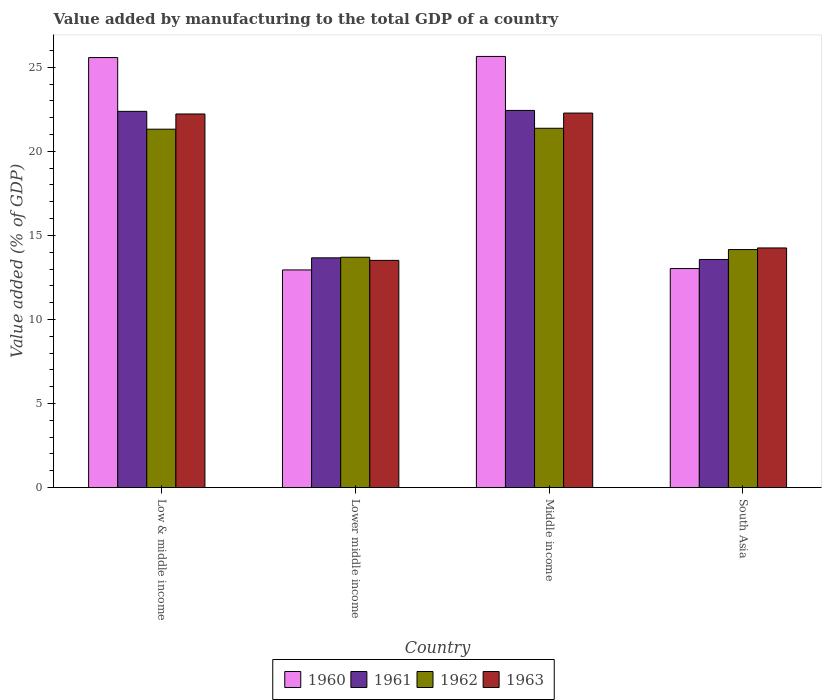How many different coloured bars are there?
Your answer should be compact. 4. How many groups of bars are there?
Make the answer very short. 4. Are the number of bars per tick equal to the number of legend labels?
Offer a terse response. Yes. Are the number of bars on each tick of the X-axis equal?
Make the answer very short. Yes. How many bars are there on the 4th tick from the left?
Ensure brevity in your answer.  4. How many bars are there on the 4th tick from the right?
Keep it short and to the point. 4. In how many cases, is the number of bars for a given country not equal to the number of legend labels?
Make the answer very short. 0. What is the value added by manufacturing to the total GDP in 1960 in Middle income?
Your answer should be compact. 25.65. Across all countries, what is the maximum value added by manufacturing to the total GDP in 1960?
Make the answer very short. 25.65. Across all countries, what is the minimum value added by manufacturing to the total GDP in 1960?
Your response must be concise. 12.95. In which country was the value added by manufacturing to the total GDP in 1960 maximum?
Offer a terse response. Middle income. In which country was the value added by manufacturing to the total GDP in 1962 minimum?
Offer a very short reply. Lower middle income. What is the total value added by manufacturing to the total GDP in 1961 in the graph?
Give a very brief answer. 72.05. What is the difference between the value added by manufacturing to the total GDP in 1960 in Low & middle income and that in Middle income?
Your answer should be compact. -0.07. What is the difference between the value added by manufacturing to the total GDP in 1962 in Lower middle income and the value added by manufacturing to the total GDP in 1963 in Middle income?
Your answer should be very brief. -8.57. What is the average value added by manufacturing to the total GDP in 1963 per country?
Provide a succinct answer. 18.07. What is the difference between the value added by manufacturing to the total GDP of/in 1960 and value added by manufacturing to the total GDP of/in 1962 in Middle income?
Your answer should be very brief. 4.27. What is the ratio of the value added by manufacturing to the total GDP in 1960 in Middle income to that in South Asia?
Provide a short and direct response. 1.97. Is the value added by manufacturing to the total GDP in 1960 in Low & middle income less than that in Lower middle income?
Provide a succinct answer. No. What is the difference between the highest and the second highest value added by manufacturing to the total GDP in 1960?
Ensure brevity in your answer.  12.62. What is the difference between the highest and the lowest value added by manufacturing to the total GDP in 1960?
Offer a terse response. 12.7. Is the sum of the value added by manufacturing to the total GDP in 1960 in Low & middle income and South Asia greater than the maximum value added by manufacturing to the total GDP in 1963 across all countries?
Your answer should be compact. Yes. What does the 1st bar from the left in Middle income represents?
Keep it short and to the point. 1960. What does the 1st bar from the right in Low & middle income represents?
Provide a short and direct response. 1963. Are all the bars in the graph horizontal?
Provide a short and direct response. No. How many countries are there in the graph?
Your response must be concise. 4. Does the graph contain grids?
Your answer should be very brief. No. How many legend labels are there?
Your answer should be very brief. 4. How are the legend labels stacked?
Offer a very short reply. Horizontal. What is the title of the graph?
Ensure brevity in your answer.  Value added by manufacturing to the total GDP of a country. Does "1979" appear as one of the legend labels in the graph?
Give a very brief answer. No. What is the label or title of the X-axis?
Provide a short and direct response. Country. What is the label or title of the Y-axis?
Give a very brief answer. Value added (% of GDP). What is the Value added (% of GDP) in 1960 in Low & middle income?
Your response must be concise. 25.58. What is the Value added (% of GDP) in 1961 in Low & middle income?
Provide a short and direct response. 22.38. What is the Value added (% of GDP) of 1962 in Low & middle income?
Offer a terse response. 21.32. What is the Value added (% of GDP) in 1963 in Low & middle income?
Your answer should be compact. 22.22. What is the Value added (% of GDP) in 1960 in Lower middle income?
Ensure brevity in your answer.  12.95. What is the Value added (% of GDP) of 1961 in Lower middle income?
Keep it short and to the point. 13.67. What is the Value added (% of GDP) in 1962 in Lower middle income?
Your answer should be very brief. 13.7. What is the Value added (% of GDP) of 1963 in Lower middle income?
Your answer should be very brief. 13.52. What is the Value added (% of GDP) of 1960 in Middle income?
Provide a short and direct response. 25.65. What is the Value added (% of GDP) of 1961 in Middle income?
Give a very brief answer. 22.44. What is the Value added (% of GDP) in 1962 in Middle income?
Your response must be concise. 21.37. What is the Value added (% of GDP) of 1963 in Middle income?
Make the answer very short. 22.28. What is the Value added (% of GDP) of 1960 in South Asia?
Provide a short and direct response. 13.03. What is the Value added (% of GDP) of 1961 in South Asia?
Give a very brief answer. 13.57. What is the Value added (% of GDP) of 1962 in South Asia?
Offer a terse response. 14.16. What is the Value added (% of GDP) of 1963 in South Asia?
Provide a succinct answer. 14.26. Across all countries, what is the maximum Value added (% of GDP) of 1960?
Your answer should be very brief. 25.65. Across all countries, what is the maximum Value added (% of GDP) in 1961?
Give a very brief answer. 22.44. Across all countries, what is the maximum Value added (% of GDP) in 1962?
Offer a terse response. 21.37. Across all countries, what is the maximum Value added (% of GDP) in 1963?
Offer a very short reply. 22.28. Across all countries, what is the minimum Value added (% of GDP) in 1960?
Your answer should be very brief. 12.95. Across all countries, what is the minimum Value added (% of GDP) of 1961?
Make the answer very short. 13.57. Across all countries, what is the minimum Value added (% of GDP) in 1962?
Your answer should be compact. 13.7. Across all countries, what is the minimum Value added (% of GDP) of 1963?
Your answer should be compact. 13.52. What is the total Value added (% of GDP) of 1960 in the graph?
Provide a short and direct response. 77.2. What is the total Value added (% of GDP) of 1961 in the graph?
Provide a succinct answer. 72.05. What is the total Value added (% of GDP) of 1962 in the graph?
Provide a succinct answer. 70.56. What is the total Value added (% of GDP) in 1963 in the graph?
Your answer should be very brief. 72.27. What is the difference between the Value added (% of GDP) in 1960 in Low & middle income and that in Lower middle income?
Your answer should be very brief. 12.63. What is the difference between the Value added (% of GDP) in 1961 in Low & middle income and that in Lower middle income?
Provide a succinct answer. 8.71. What is the difference between the Value added (% of GDP) of 1962 in Low & middle income and that in Lower middle income?
Provide a short and direct response. 7.62. What is the difference between the Value added (% of GDP) in 1963 in Low & middle income and that in Lower middle income?
Provide a short and direct response. 8.71. What is the difference between the Value added (% of GDP) in 1960 in Low & middle income and that in Middle income?
Make the answer very short. -0.07. What is the difference between the Value added (% of GDP) of 1961 in Low & middle income and that in Middle income?
Your answer should be very brief. -0.06. What is the difference between the Value added (% of GDP) in 1962 in Low & middle income and that in Middle income?
Offer a terse response. -0.05. What is the difference between the Value added (% of GDP) of 1963 in Low & middle income and that in Middle income?
Make the answer very short. -0.05. What is the difference between the Value added (% of GDP) in 1960 in Low & middle income and that in South Asia?
Provide a succinct answer. 12.55. What is the difference between the Value added (% of GDP) in 1961 in Low & middle income and that in South Asia?
Ensure brevity in your answer.  8.81. What is the difference between the Value added (% of GDP) of 1962 in Low & middle income and that in South Asia?
Keep it short and to the point. 7.16. What is the difference between the Value added (% of GDP) in 1963 in Low & middle income and that in South Asia?
Offer a very short reply. 7.97. What is the difference between the Value added (% of GDP) in 1960 in Lower middle income and that in Middle income?
Provide a short and direct response. -12.7. What is the difference between the Value added (% of GDP) of 1961 in Lower middle income and that in Middle income?
Offer a very short reply. -8.77. What is the difference between the Value added (% of GDP) in 1962 in Lower middle income and that in Middle income?
Ensure brevity in your answer.  -7.67. What is the difference between the Value added (% of GDP) in 1963 in Lower middle income and that in Middle income?
Offer a terse response. -8.76. What is the difference between the Value added (% of GDP) in 1960 in Lower middle income and that in South Asia?
Your answer should be compact. -0.08. What is the difference between the Value added (% of GDP) of 1961 in Lower middle income and that in South Asia?
Ensure brevity in your answer.  0.1. What is the difference between the Value added (% of GDP) of 1962 in Lower middle income and that in South Asia?
Provide a succinct answer. -0.46. What is the difference between the Value added (% of GDP) in 1963 in Lower middle income and that in South Asia?
Give a very brief answer. -0.74. What is the difference between the Value added (% of GDP) in 1960 in Middle income and that in South Asia?
Your answer should be compact. 12.62. What is the difference between the Value added (% of GDP) of 1961 in Middle income and that in South Asia?
Keep it short and to the point. 8.87. What is the difference between the Value added (% of GDP) in 1962 in Middle income and that in South Asia?
Your response must be concise. 7.21. What is the difference between the Value added (% of GDP) of 1963 in Middle income and that in South Asia?
Your answer should be very brief. 8.02. What is the difference between the Value added (% of GDP) in 1960 in Low & middle income and the Value added (% of GDP) in 1961 in Lower middle income?
Your response must be concise. 11.91. What is the difference between the Value added (% of GDP) in 1960 in Low & middle income and the Value added (% of GDP) in 1962 in Lower middle income?
Offer a terse response. 11.88. What is the difference between the Value added (% of GDP) in 1960 in Low & middle income and the Value added (% of GDP) in 1963 in Lower middle income?
Provide a short and direct response. 12.06. What is the difference between the Value added (% of GDP) of 1961 in Low & middle income and the Value added (% of GDP) of 1962 in Lower middle income?
Your answer should be compact. 8.68. What is the difference between the Value added (% of GDP) of 1961 in Low & middle income and the Value added (% of GDP) of 1963 in Lower middle income?
Offer a terse response. 8.86. What is the difference between the Value added (% of GDP) in 1962 in Low & middle income and the Value added (% of GDP) in 1963 in Lower middle income?
Provide a short and direct response. 7.8. What is the difference between the Value added (% of GDP) in 1960 in Low & middle income and the Value added (% of GDP) in 1961 in Middle income?
Offer a terse response. 3.14. What is the difference between the Value added (% of GDP) in 1960 in Low & middle income and the Value added (% of GDP) in 1962 in Middle income?
Keep it short and to the point. 4.21. What is the difference between the Value added (% of GDP) of 1960 in Low & middle income and the Value added (% of GDP) of 1963 in Middle income?
Your response must be concise. 3.3. What is the difference between the Value added (% of GDP) in 1961 in Low & middle income and the Value added (% of GDP) in 1962 in Middle income?
Keep it short and to the point. 1.01. What is the difference between the Value added (% of GDP) in 1961 in Low & middle income and the Value added (% of GDP) in 1963 in Middle income?
Your answer should be compact. 0.1. What is the difference between the Value added (% of GDP) of 1962 in Low & middle income and the Value added (% of GDP) of 1963 in Middle income?
Make the answer very short. -0.96. What is the difference between the Value added (% of GDP) in 1960 in Low & middle income and the Value added (% of GDP) in 1961 in South Asia?
Your answer should be very brief. 12.01. What is the difference between the Value added (% of GDP) of 1960 in Low & middle income and the Value added (% of GDP) of 1962 in South Asia?
Your answer should be very brief. 11.42. What is the difference between the Value added (% of GDP) in 1960 in Low & middle income and the Value added (% of GDP) in 1963 in South Asia?
Offer a terse response. 11.32. What is the difference between the Value added (% of GDP) of 1961 in Low & middle income and the Value added (% of GDP) of 1962 in South Asia?
Provide a short and direct response. 8.22. What is the difference between the Value added (% of GDP) of 1961 in Low & middle income and the Value added (% of GDP) of 1963 in South Asia?
Make the answer very short. 8.12. What is the difference between the Value added (% of GDP) of 1962 in Low & middle income and the Value added (% of GDP) of 1963 in South Asia?
Your answer should be compact. 7.06. What is the difference between the Value added (% of GDP) of 1960 in Lower middle income and the Value added (% of GDP) of 1961 in Middle income?
Provide a short and direct response. -9.49. What is the difference between the Value added (% of GDP) of 1960 in Lower middle income and the Value added (% of GDP) of 1962 in Middle income?
Offer a very short reply. -8.43. What is the difference between the Value added (% of GDP) of 1960 in Lower middle income and the Value added (% of GDP) of 1963 in Middle income?
Your answer should be very brief. -9.33. What is the difference between the Value added (% of GDP) in 1961 in Lower middle income and the Value added (% of GDP) in 1962 in Middle income?
Your answer should be compact. -7.71. What is the difference between the Value added (% of GDP) of 1961 in Lower middle income and the Value added (% of GDP) of 1963 in Middle income?
Offer a terse response. -8.61. What is the difference between the Value added (% of GDP) of 1962 in Lower middle income and the Value added (% of GDP) of 1963 in Middle income?
Provide a succinct answer. -8.57. What is the difference between the Value added (% of GDP) in 1960 in Lower middle income and the Value added (% of GDP) in 1961 in South Asia?
Offer a terse response. -0.62. What is the difference between the Value added (% of GDP) of 1960 in Lower middle income and the Value added (% of GDP) of 1962 in South Asia?
Give a very brief answer. -1.21. What is the difference between the Value added (% of GDP) of 1960 in Lower middle income and the Value added (% of GDP) of 1963 in South Asia?
Give a very brief answer. -1.31. What is the difference between the Value added (% of GDP) in 1961 in Lower middle income and the Value added (% of GDP) in 1962 in South Asia?
Offer a very short reply. -0.49. What is the difference between the Value added (% of GDP) of 1961 in Lower middle income and the Value added (% of GDP) of 1963 in South Asia?
Provide a short and direct response. -0.59. What is the difference between the Value added (% of GDP) in 1962 in Lower middle income and the Value added (% of GDP) in 1963 in South Asia?
Provide a short and direct response. -0.55. What is the difference between the Value added (% of GDP) in 1960 in Middle income and the Value added (% of GDP) in 1961 in South Asia?
Provide a short and direct response. 12.08. What is the difference between the Value added (% of GDP) in 1960 in Middle income and the Value added (% of GDP) in 1962 in South Asia?
Offer a very short reply. 11.49. What is the difference between the Value added (% of GDP) in 1960 in Middle income and the Value added (% of GDP) in 1963 in South Asia?
Give a very brief answer. 11.39. What is the difference between the Value added (% of GDP) in 1961 in Middle income and the Value added (% of GDP) in 1962 in South Asia?
Provide a short and direct response. 8.28. What is the difference between the Value added (% of GDP) of 1961 in Middle income and the Value added (% of GDP) of 1963 in South Asia?
Ensure brevity in your answer.  8.18. What is the difference between the Value added (% of GDP) of 1962 in Middle income and the Value added (% of GDP) of 1963 in South Asia?
Your answer should be very brief. 7.12. What is the average Value added (% of GDP) in 1960 per country?
Offer a terse response. 19.3. What is the average Value added (% of GDP) in 1961 per country?
Offer a very short reply. 18.01. What is the average Value added (% of GDP) in 1962 per country?
Offer a terse response. 17.64. What is the average Value added (% of GDP) of 1963 per country?
Offer a very short reply. 18.07. What is the difference between the Value added (% of GDP) in 1960 and Value added (% of GDP) in 1961 in Low & middle income?
Provide a short and direct response. 3.2. What is the difference between the Value added (% of GDP) of 1960 and Value added (% of GDP) of 1962 in Low & middle income?
Offer a terse response. 4.26. What is the difference between the Value added (% of GDP) of 1960 and Value added (% of GDP) of 1963 in Low & middle income?
Give a very brief answer. 3.35. What is the difference between the Value added (% of GDP) in 1961 and Value added (% of GDP) in 1962 in Low & middle income?
Keep it short and to the point. 1.06. What is the difference between the Value added (% of GDP) of 1961 and Value added (% of GDP) of 1963 in Low & middle income?
Give a very brief answer. 0.16. What is the difference between the Value added (% of GDP) of 1962 and Value added (% of GDP) of 1963 in Low & middle income?
Provide a short and direct response. -0.9. What is the difference between the Value added (% of GDP) in 1960 and Value added (% of GDP) in 1961 in Lower middle income?
Your response must be concise. -0.72. What is the difference between the Value added (% of GDP) in 1960 and Value added (% of GDP) in 1962 in Lower middle income?
Offer a terse response. -0.75. What is the difference between the Value added (% of GDP) in 1960 and Value added (% of GDP) in 1963 in Lower middle income?
Your answer should be compact. -0.57. What is the difference between the Value added (% of GDP) of 1961 and Value added (% of GDP) of 1962 in Lower middle income?
Offer a terse response. -0.04. What is the difference between the Value added (% of GDP) of 1961 and Value added (% of GDP) of 1963 in Lower middle income?
Provide a short and direct response. 0.15. What is the difference between the Value added (% of GDP) in 1962 and Value added (% of GDP) in 1963 in Lower middle income?
Your response must be concise. 0.19. What is the difference between the Value added (% of GDP) of 1960 and Value added (% of GDP) of 1961 in Middle income?
Offer a terse response. 3.21. What is the difference between the Value added (% of GDP) in 1960 and Value added (% of GDP) in 1962 in Middle income?
Your response must be concise. 4.27. What is the difference between the Value added (% of GDP) of 1960 and Value added (% of GDP) of 1963 in Middle income?
Provide a succinct answer. 3.37. What is the difference between the Value added (% of GDP) of 1961 and Value added (% of GDP) of 1962 in Middle income?
Your response must be concise. 1.06. What is the difference between the Value added (% of GDP) of 1961 and Value added (% of GDP) of 1963 in Middle income?
Provide a short and direct response. 0.16. What is the difference between the Value added (% of GDP) in 1962 and Value added (% of GDP) in 1963 in Middle income?
Offer a very short reply. -0.9. What is the difference between the Value added (% of GDP) in 1960 and Value added (% of GDP) in 1961 in South Asia?
Your answer should be very brief. -0.54. What is the difference between the Value added (% of GDP) in 1960 and Value added (% of GDP) in 1962 in South Asia?
Your answer should be very brief. -1.13. What is the difference between the Value added (% of GDP) of 1960 and Value added (% of GDP) of 1963 in South Asia?
Give a very brief answer. -1.23. What is the difference between the Value added (% of GDP) in 1961 and Value added (% of GDP) in 1962 in South Asia?
Ensure brevity in your answer.  -0.59. What is the difference between the Value added (% of GDP) in 1961 and Value added (% of GDP) in 1963 in South Asia?
Your response must be concise. -0.69. What is the difference between the Value added (% of GDP) of 1962 and Value added (% of GDP) of 1963 in South Asia?
Ensure brevity in your answer.  -0.1. What is the ratio of the Value added (% of GDP) in 1960 in Low & middle income to that in Lower middle income?
Your answer should be compact. 1.98. What is the ratio of the Value added (% of GDP) in 1961 in Low & middle income to that in Lower middle income?
Provide a succinct answer. 1.64. What is the ratio of the Value added (% of GDP) in 1962 in Low & middle income to that in Lower middle income?
Make the answer very short. 1.56. What is the ratio of the Value added (% of GDP) of 1963 in Low & middle income to that in Lower middle income?
Your answer should be very brief. 1.64. What is the ratio of the Value added (% of GDP) of 1960 in Low & middle income to that in Middle income?
Your response must be concise. 1. What is the ratio of the Value added (% of GDP) of 1961 in Low & middle income to that in Middle income?
Your answer should be very brief. 1. What is the ratio of the Value added (% of GDP) in 1962 in Low & middle income to that in Middle income?
Your answer should be compact. 1. What is the ratio of the Value added (% of GDP) in 1960 in Low & middle income to that in South Asia?
Provide a succinct answer. 1.96. What is the ratio of the Value added (% of GDP) of 1961 in Low & middle income to that in South Asia?
Your answer should be compact. 1.65. What is the ratio of the Value added (% of GDP) in 1962 in Low & middle income to that in South Asia?
Your answer should be very brief. 1.51. What is the ratio of the Value added (% of GDP) in 1963 in Low & middle income to that in South Asia?
Offer a very short reply. 1.56. What is the ratio of the Value added (% of GDP) of 1960 in Lower middle income to that in Middle income?
Provide a succinct answer. 0.5. What is the ratio of the Value added (% of GDP) of 1961 in Lower middle income to that in Middle income?
Provide a short and direct response. 0.61. What is the ratio of the Value added (% of GDP) of 1962 in Lower middle income to that in Middle income?
Your answer should be very brief. 0.64. What is the ratio of the Value added (% of GDP) of 1963 in Lower middle income to that in Middle income?
Offer a very short reply. 0.61. What is the ratio of the Value added (% of GDP) of 1960 in Lower middle income to that in South Asia?
Your response must be concise. 0.99. What is the ratio of the Value added (% of GDP) in 1963 in Lower middle income to that in South Asia?
Keep it short and to the point. 0.95. What is the ratio of the Value added (% of GDP) in 1960 in Middle income to that in South Asia?
Your answer should be very brief. 1.97. What is the ratio of the Value added (% of GDP) in 1961 in Middle income to that in South Asia?
Offer a very short reply. 1.65. What is the ratio of the Value added (% of GDP) in 1962 in Middle income to that in South Asia?
Provide a short and direct response. 1.51. What is the ratio of the Value added (% of GDP) in 1963 in Middle income to that in South Asia?
Keep it short and to the point. 1.56. What is the difference between the highest and the second highest Value added (% of GDP) of 1960?
Provide a succinct answer. 0.07. What is the difference between the highest and the second highest Value added (% of GDP) in 1961?
Keep it short and to the point. 0.06. What is the difference between the highest and the second highest Value added (% of GDP) in 1962?
Your response must be concise. 0.05. What is the difference between the highest and the second highest Value added (% of GDP) of 1963?
Keep it short and to the point. 0.05. What is the difference between the highest and the lowest Value added (% of GDP) of 1960?
Your answer should be very brief. 12.7. What is the difference between the highest and the lowest Value added (% of GDP) of 1961?
Give a very brief answer. 8.87. What is the difference between the highest and the lowest Value added (% of GDP) in 1962?
Your answer should be very brief. 7.67. What is the difference between the highest and the lowest Value added (% of GDP) in 1963?
Your response must be concise. 8.76. 